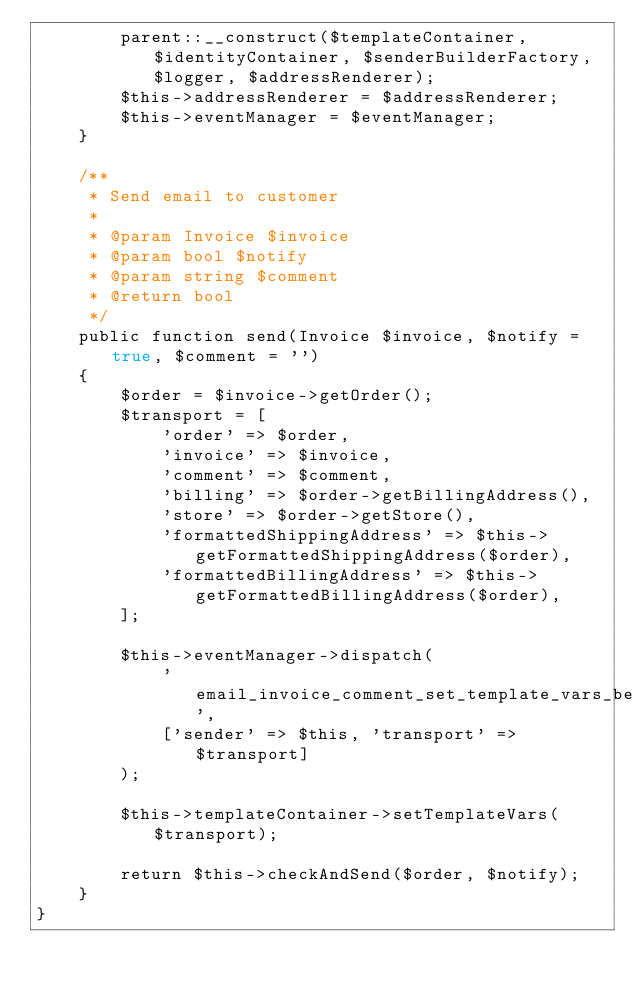<code> <loc_0><loc_0><loc_500><loc_500><_PHP_>        parent::__construct($templateContainer, $identityContainer, $senderBuilderFactory, $logger, $addressRenderer);
        $this->addressRenderer = $addressRenderer;
        $this->eventManager = $eventManager;
    }

    /**
     * Send email to customer
     *
     * @param Invoice $invoice
     * @param bool $notify
     * @param string $comment
     * @return bool
     */
    public function send(Invoice $invoice, $notify = true, $comment = '')
    {
        $order = $invoice->getOrder();
        $transport = [
            'order' => $order,
            'invoice' => $invoice,
            'comment' => $comment,
            'billing' => $order->getBillingAddress(),
            'store' => $order->getStore(),
            'formattedShippingAddress' => $this->getFormattedShippingAddress($order),
            'formattedBillingAddress' => $this->getFormattedBillingAddress($order),
        ];

        $this->eventManager->dispatch(
            'email_invoice_comment_set_template_vars_before',
            ['sender' => $this, 'transport' => $transport]
        );

        $this->templateContainer->setTemplateVars($transport);

        return $this->checkAndSend($order, $notify);
    }
}
</code> 